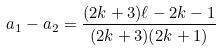Convert formula to latex. <formula><loc_0><loc_0><loc_500><loc_500>a _ { 1 } - a _ { 2 } = \frac { ( 2 k + 3 ) \ell - 2 k - 1 } { ( 2 k + 3 ) ( 2 k + 1 ) }</formula> 